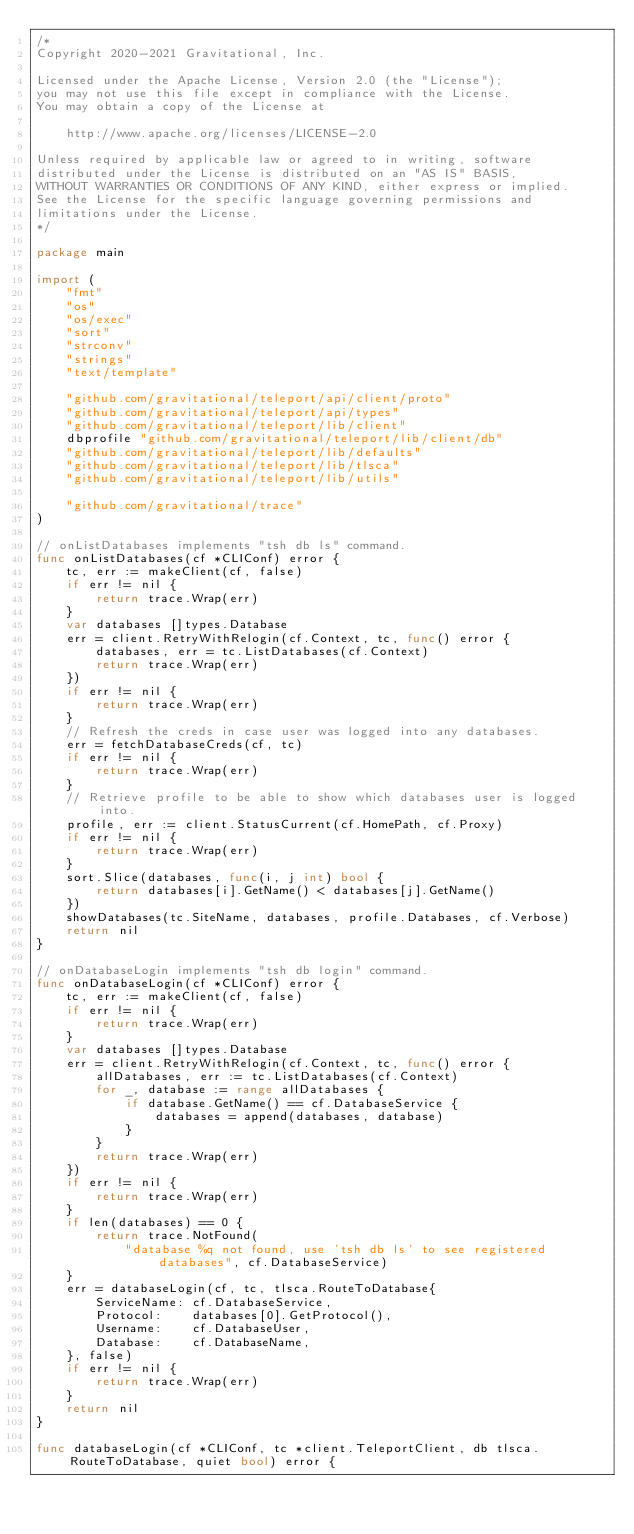Convert code to text. <code><loc_0><loc_0><loc_500><loc_500><_Go_>/*
Copyright 2020-2021 Gravitational, Inc.

Licensed under the Apache License, Version 2.0 (the "License");
you may not use this file except in compliance with the License.
You may obtain a copy of the License at

    http://www.apache.org/licenses/LICENSE-2.0

Unless required by applicable law or agreed to in writing, software
distributed under the License is distributed on an "AS IS" BASIS,
WITHOUT WARRANTIES OR CONDITIONS OF ANY KIND, either express or implied.
See the License for the specific language governing permissions and
limitations under the License.
*/

package main

import (
	"fmt"
	"os"
	"os/exec"
	"sort"
	"strconv"
	"strings"
	"text/template"

	"github.com/gravitational/teleport/api/client/proto"
	"github.com/gravitational/teleport/api/types"
	"github.com/gravitational/teleport/lib/client"
	dbprofile "github.com/gravitational/teleport/lib/client/db"
	"github.com/gravitational/teleport/lib/defaults"
	"github.com/gravitational/teleport/lib/tlsca"
	"github.com/gravitational/teleport/lib/utils"

	"github.com/gravitational/trace"
)

// onListDatabases implements "tsh db ls" command.
func onListDatabases(cf *CLIConf) error {
	tc, err := makeClient(cf, false)
	if err != nil {
		return trace.Wrap(err)
	}
	var databases []types.Database
	err = client.RetryWithRelogin(cf.Context, tc, func() error {
		databases, err = tc.ListDatabases(cf.Context)
		return trace.Wrap(err)
	})
	if err != nil {
		return trace.Wrap(err)
	}
	// Refresh the creds in case user was logged into any databases.
	err = fetchDatabaseCreds(cf, tc)
	if err != nil {
		return trace.Wrap(err)
	}
	// Retrieve profile to be able to show which databases user is logged into.
	profile, err := client.StatusCurrent(cf.HomePath, cf.Proxy)
	if err != nil {
		return trace.Wrap(err)
	}
	sort.Slice(databases, func(i, j int) bool {
		return databases[i].GetName() < databases[j].GetName()
	})
	showDatabases(tc.SiteName, databases, profile.Databases, cf.Verbose)
	return nil
}

// onDatabaseLogin implements "tsh db login" command.
func onDatabaseLogin(cf *CLIConf) error {
	tc, err := makeClient(cf, false)
	if err != nil {
		return trace.Wrap(err)
	}
	var databases []types.Database
	err = client.RetryWithRelogin(cf.Context, tc, func() error {
		allDatabases, err := tc.ListDatabases(cf.Context)
		for _, database := range allDatabases {
			if database.GetName() == cf.DatabaseService {
				databases = append(databases, database)
			}
		}
		return trace.Wrap(err)
	})
	if err != nil {
		return trace.Wrap(err)
	}
	if len(databases) == 0 {
		return trace.NotFound(
			"database %q not found, use 'tsh db ls' to see registered databases", cf.DatabaseService)
	}
	err = databaseLogin(cf, tc, tlsca.RouteToDatabase{
		ServiceName: cf.DatabaseService,
		Protocol:    databases[0].GetProtocol(),
		Username:    cf.DatabaseUser,
		Database:    cf.DatabaseName,
	}, false)
	if err != nil {
		return trace.Wrap(err)
	}
	return nil
}

func databaseLogin(cf *CLIConf, tc *client.TeleportClient, db tlsca.RouteToDatabase, quiet bool) error {</code> 